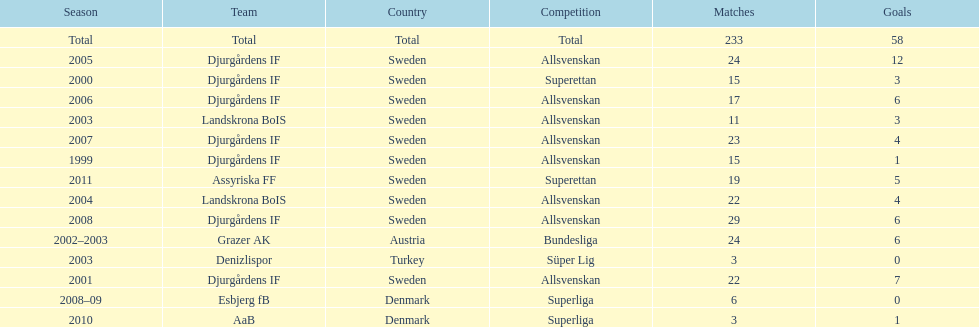How many total goals has jones kusi-asare scored? 58. 